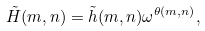<formula> <loc_0><loc_0><loc_500><loc_500>\tilde { H } ( m , n ) = \tilde { h } ( m , n ) \omega ^ { \theta ( m , n ) } ,</formula> 